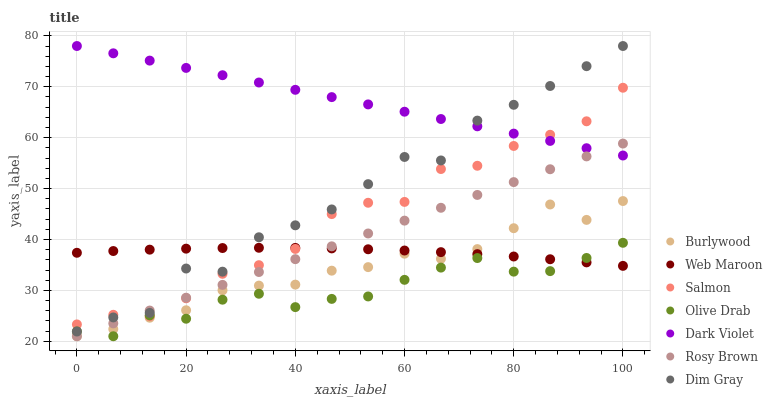Does Olive Drab have the minimum area under the curve?
Answer yes or no. Yes. Does Dark Violet have the maximum area under the curve?
Answer yes or no. Yes. Does Burlywood have the minimum area under the curve?
Answer yes or no. No. Does Burlywood have the maximum area under the curve?
Answer yes or no. No. Is Rosy Brown the smoothest?
Answer yes or no. Yes. Is Dim Gray the roughest?
Answer yes or no. Yes. Is Burlywood the smoothest?
Answer yes or no. No. Is Burlywood the roughest?
Answer yes or no. No. Does Burlywood have the lowest value?
Answer yes or no. Yes. Does Web Maroon have the lowest value?
Answer yes or no. No. Does Dark Violet have the highest value?
Answer yes or no. Yes. Does Burlywood have the highest value?
Answer yes or no. No. Is Olive Drab less than Dark Violet?
Answer yes or no. Yes. Is Dim Gray greater than Burlywood?
Answer yes or no. Yes. Does Web Maroon intersect Olive Drab?
Answer yes or no. Yes. Is Web Maroon less than Olive Drab?
Answer yes or no. No. Is Web Maroon greater than Olive Drab?
Answer yes or no. No. Does Olive Drab intersect Dark Violet?
Answer yes or no. No. 